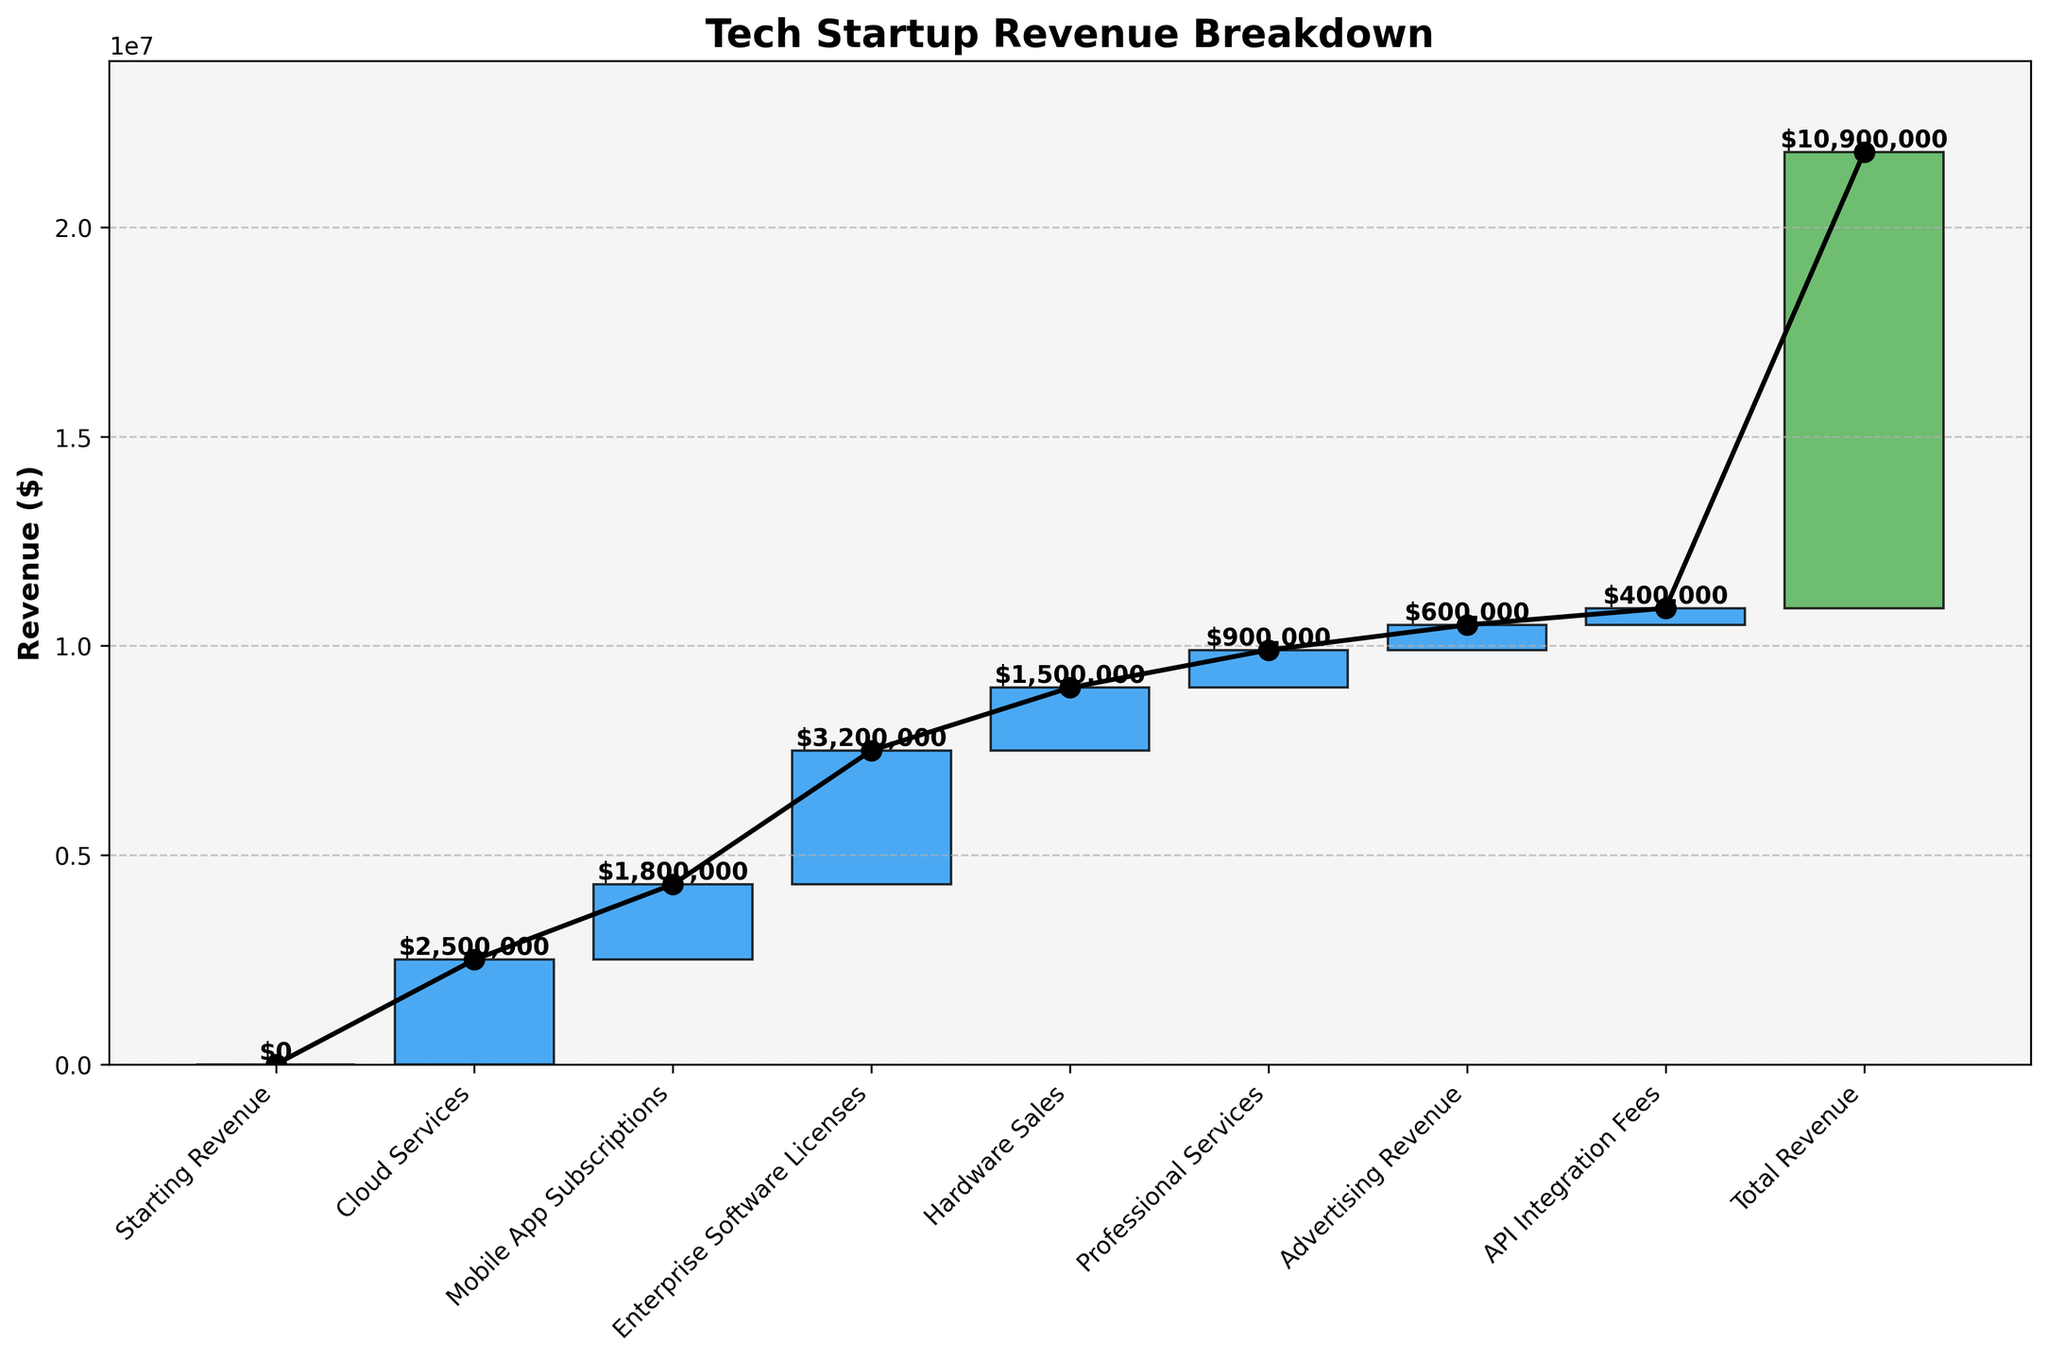What is the title of the chart? The title is typically placed at the top of the chart for easy identification. It summarizes what the chart is about.
Answer: Tech Startup Revenue Breakdown How many categories are represented in the waterfall chart? Count the unique categories listed on the x-axis of the chart.
Answer: 8 What is the starting revenue for the tech startup? The starting revenue is usually indicated at the beginning of the waterfall chart, often in a different color to signify it is the starting point.
Answer: $0 Which category contributes the most to the total revenue? Identify the bar that is the tallest or has the highest positive value added to the cumulative total.
Answer: Enterprise Software Licenses Which category has the least contribution to the revenue growth? Identify the bar with the lowest positive value added to the cumulative total after the starting point if there are no negative values.
Answer: API Integration Fees What is the total revenue recorded at the end of the analysis? The final bar in a waterfall chart usually represents the total accumulated revenue, which combines all the previous increments.
Answer: $10,900,000 Compare the contributions of Cloud Services and Mobile App Subscriptions. Which one is higher and by how much? Locate the bars for Cloud Services and Mobile App Subscriptions on the chart, then subtract the smaller value from the larger to find the difference.
Answer: Cloud Services is higher by $700,000 How much revenue is contributed by the combination of Hardware Sales and Mobile App Subscriptions? Find the values for both categories, then add them together to get the combined contribution.
Answer: $3,300,000 What is the cumulative revenue after adding Professional Services? Add the value of Professional Services to the cumulative total of the categories before it in sequence from the starting point.
Answer: $5,800,000 In which category does the cumulative revenue first exceed $7,000,000? Sum the values in order from the starting point until the cumulative total surpasses $7,000,000, then note the corresponding category.
Answer: Hardware Sales 